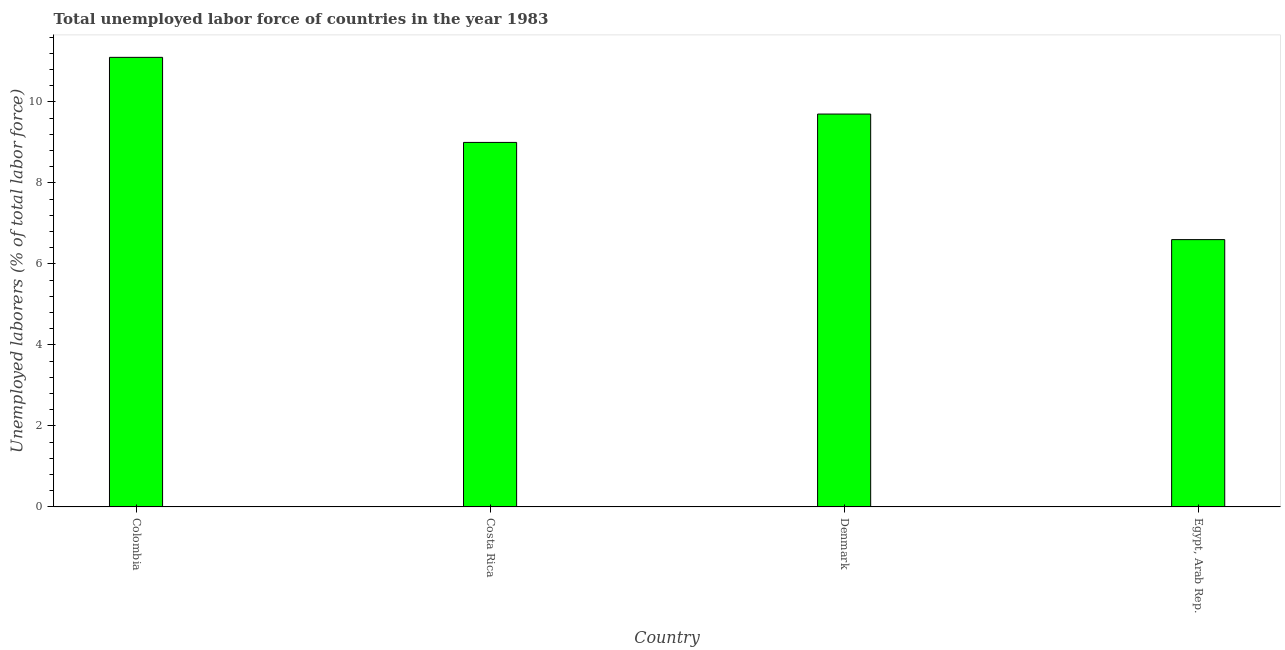Does the graph contain grids?
Ensure brevity in your answer.  No. What is the title of the graph?
Your answer should be very brief. Total unemployed labor force of countries in the year 1983. What is the label or title of the Y-axis?
Your answer should be compact. Unemployed laborers (% of total labor force). What is the total unemployed labour force in Colombia?
Make the answer very short. 11.1. Across all countries, what is the maximum total unemployed labour force?
Your answer should be very brief. 11.1. Across all countries, what is the minimum total unemployed labour force?
Ensure brevity in your answer.  6.6. In which country was the total unemployed labour force minimum?
Your response must be concise. Egypt, Arab Rep. What is the sum of the total unemployed labour force?
Your answer should be very brief. 36.4. What is the average total unemployed labour force per country?
Offer a terse response. 9.1. What is the median total unemployed labour force?
Make the answer very short. 9.35. In how many countries, is the total unemployed labour force greater than 10.8 %?
Give a very brief answer. 1. What is the ratio of the total unemployed labour force in Denmark to that in Egypt, Arab Rep.?
Your answer should be very brief. 1.47. Is the total unemployed labour force in Costa Rica less than that in Egypt, Arab Rep.?
Your response must be concise. No. Is the difference between the total unemployed labour force in Costa Rica and Denmark greater than the difference between any two countries?
Keep it short and to the point. No. Is the sum of the total unemployed labour force in Costa Rica and Egypt, Arab Rep. greater than the maximum total unemployed labour force across all countries?
Give a very brief answer. Yes. How many bars are there?
Ensure brevity in your answer.  4. Are all the bars in the graph horizontal?
Offer a very short reply. No. What is the difference between two consecutive major ticks on the Y-axis?
Keep it short and to the point. 2. What is the Unemployed laborers (% of total labor force) in Colombia?
Your response must be concise. 11.1. What is the Unemployed laborers (% of total labor force) of Denmark?
Ensure brevity in your answer.  9.7. What is the Unemployed laborers (% of total labor force) in Egypt, Arab Rep.?
Make the answer very short. 6.6. What is the difference between the Unemployed laborers (% of total labor force) in Colombia and Egypt, Arab Rep.?
Ensure brevity in your answer.  4.5. What is the difference between the Unemployed laborers (% of total labor force) in Costa Rica and Denmark?
Make the answer very short. -0.7. What is the difference between the Unemployed laborers (% of total labor force) in Costa Rica and Egypt, Arab Rep.?
Your response must be concise. 2.4. What is the ratio of the Unemployed laborers (% of total labor force) in Colombia to that in Costa Rica?
Your response must be concise. 1.23. What is the ratio of the Unemployed laborers (% of total labor force) in Colombia to that in Denmark?
Offer a terse response. 1.14. What is the ratio of the Unemployed laborers (% of total labor force) in Colombia to that in Egypt, Arab Rep.?
Your answer should be very brief. 1.68. What is the ratio of the Unemployed laborers (% of total labor force) in Costa Rica to that in Denmark?
Your answer should be very brief. 0.93. What is the ratio of the Unemployed laborers (% of total labor force) in Costa Rica to that in Egypt, Arab Rep.?
Provide a succinct answer. 1.36. What is the ratio of the Unemployed laborers (% of total labor force) in Denmark to that in Egypt, Arab Rep.?
Provide a succinct answer. 1.47. 